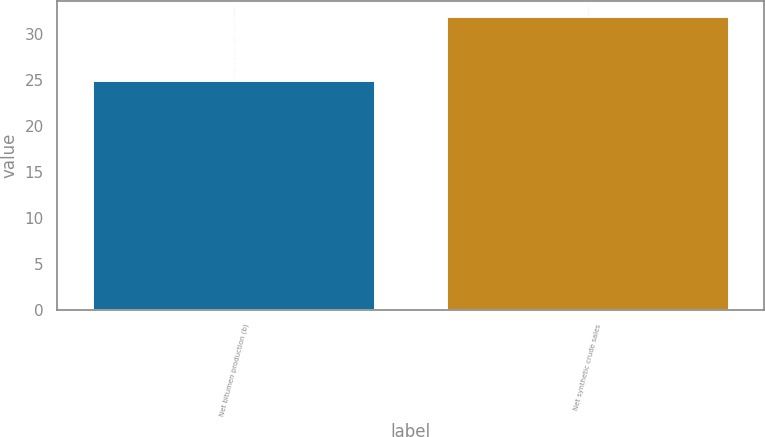Convert chart to OTSL. <chart><loc_0><loc_0><loc_500><loc_500><bar_chart><fcel>Net bitumen production (b)<fcel>Net synthetic crude sales<nl><fcel>25<fcel>32<nl></chart> 